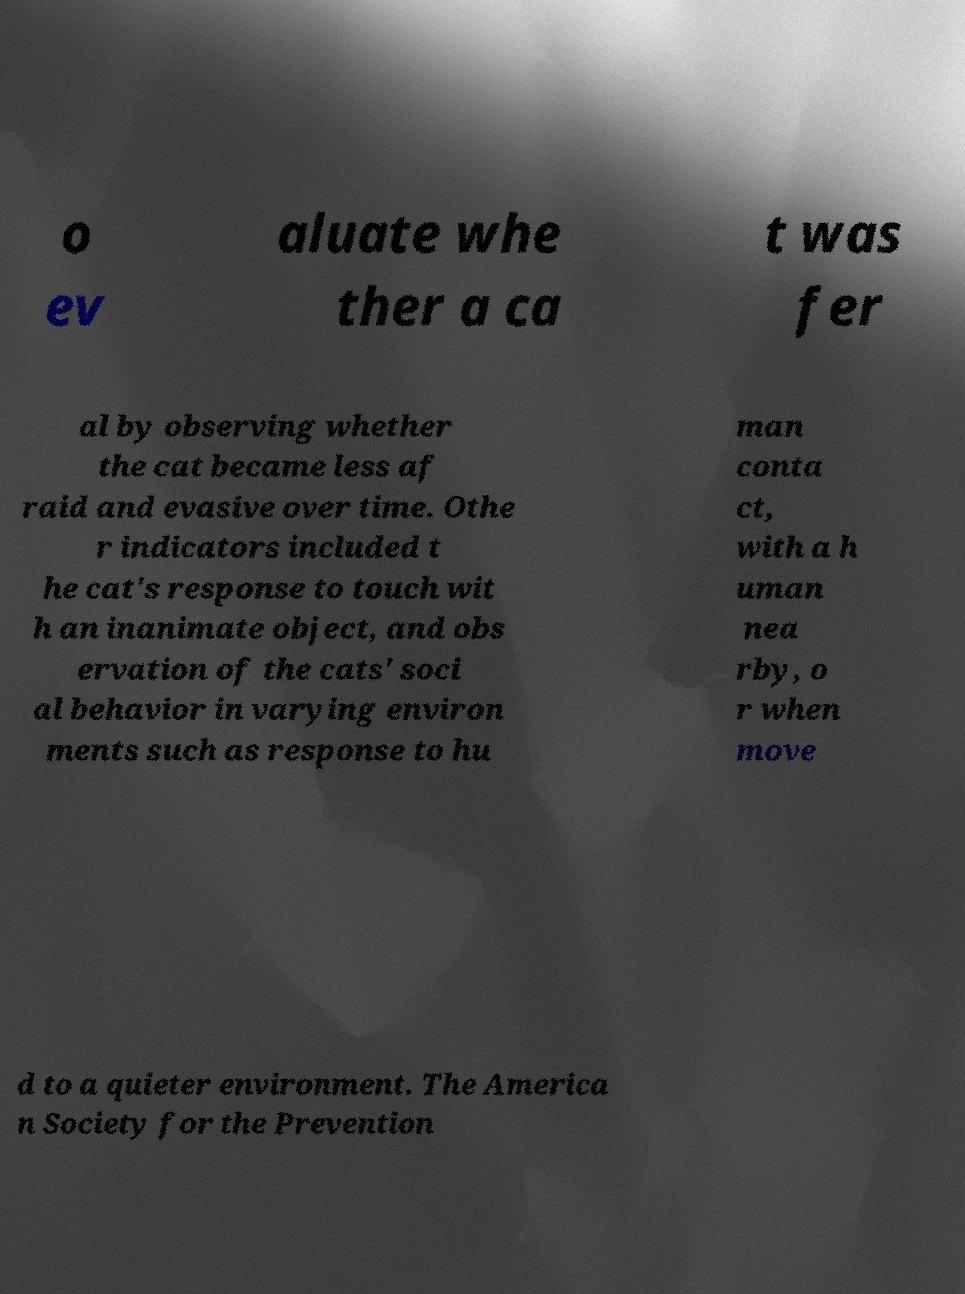Can you accurately transcribe the text from the provided image for me? o ev aluate whe ther a ca t was fer al by observing whether the cat became less af raid and evasive over time. Othe r indicators included t he cat's response to touch wit h an inanimate object, and obs ervation of the cats' soci al behavior in varying environ ments such as response to hu man conta ct, with a h uman nea rby, o r when move d to a quieter environment. The America n Society for the Prevention 